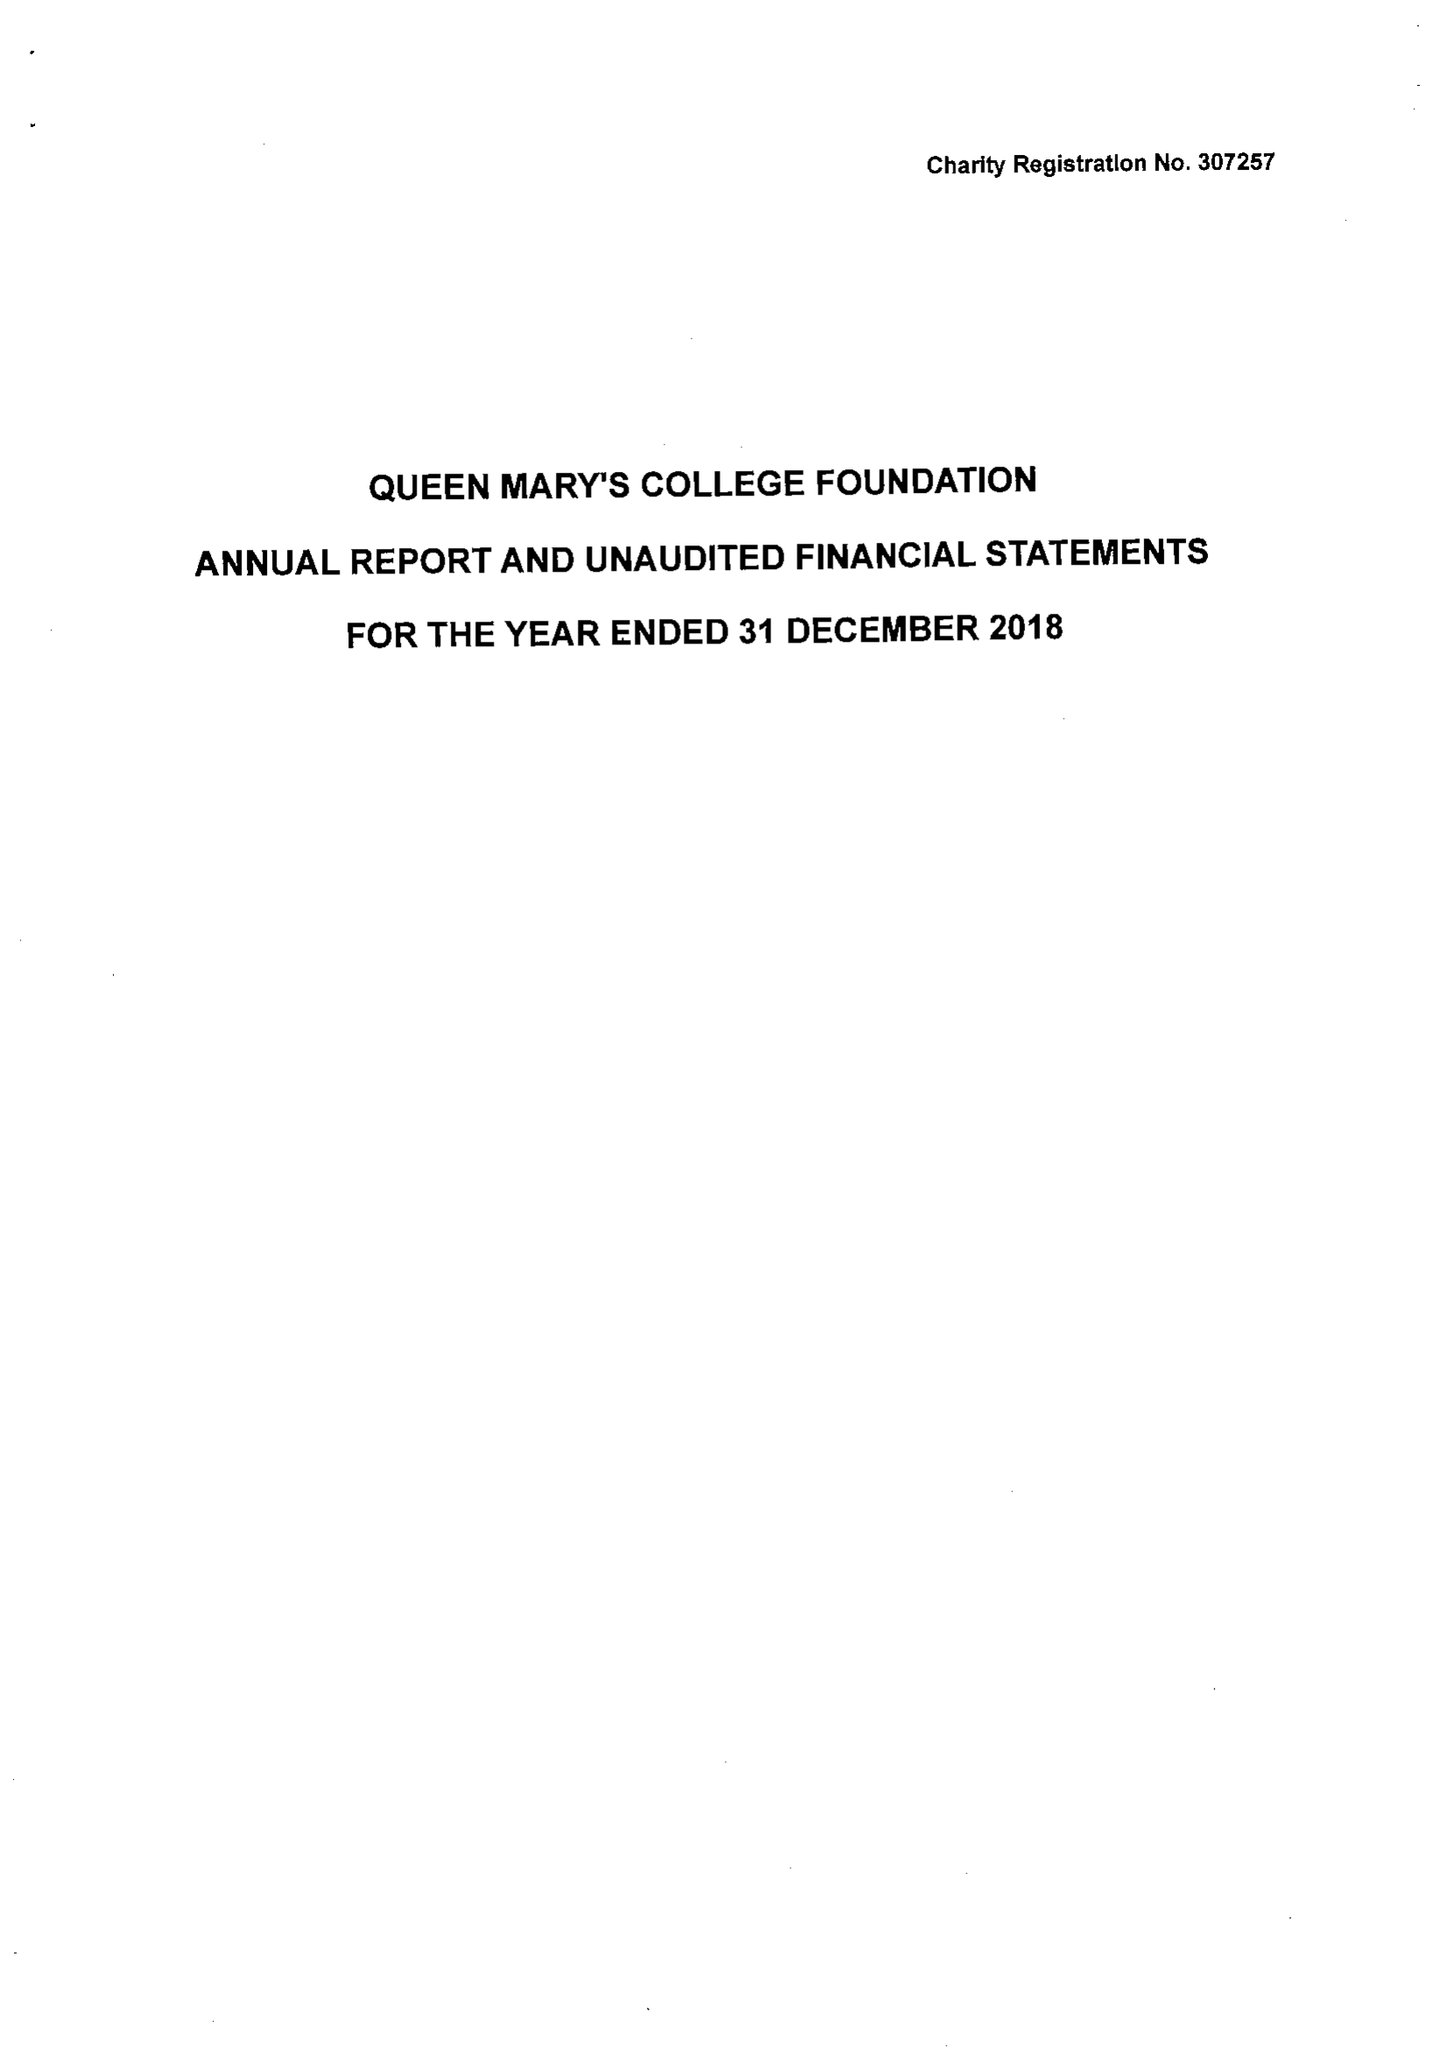What is the value for the income_annually_in_british_pounds?
Answer the question using a single word or phrase. 68070.00 